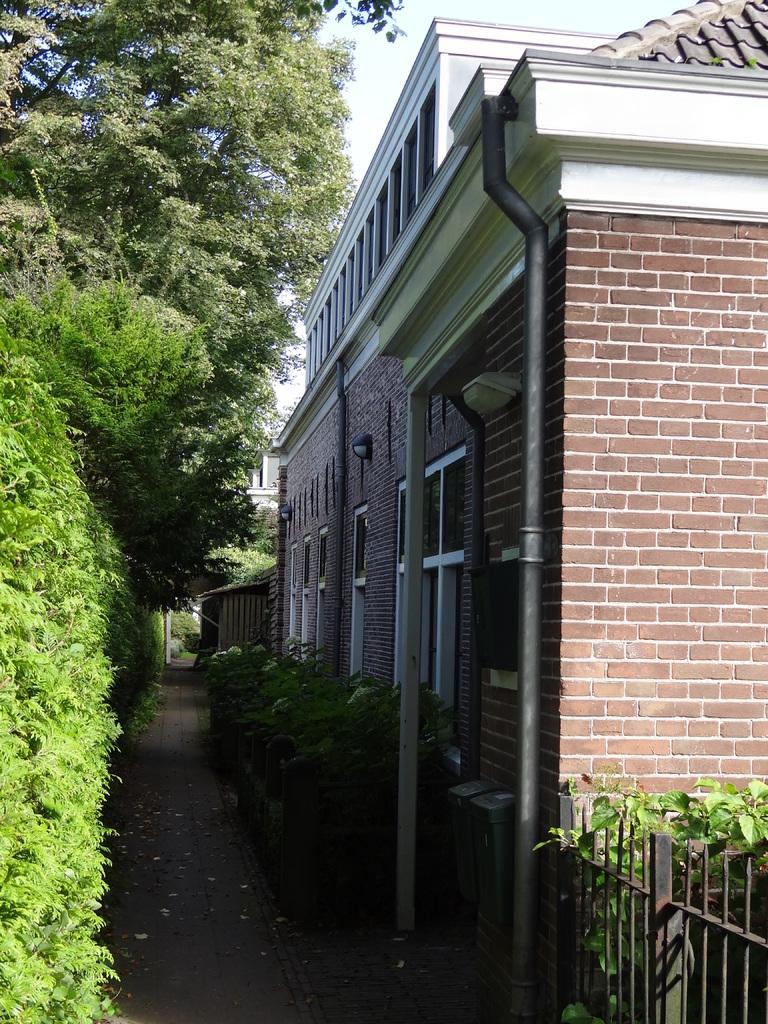Please provide a concise description of this image. In the image in the center we can see trees,plants,grass,poles,windows,building,roof,wall,fence etc. In the background we can see the sky and clouds. 